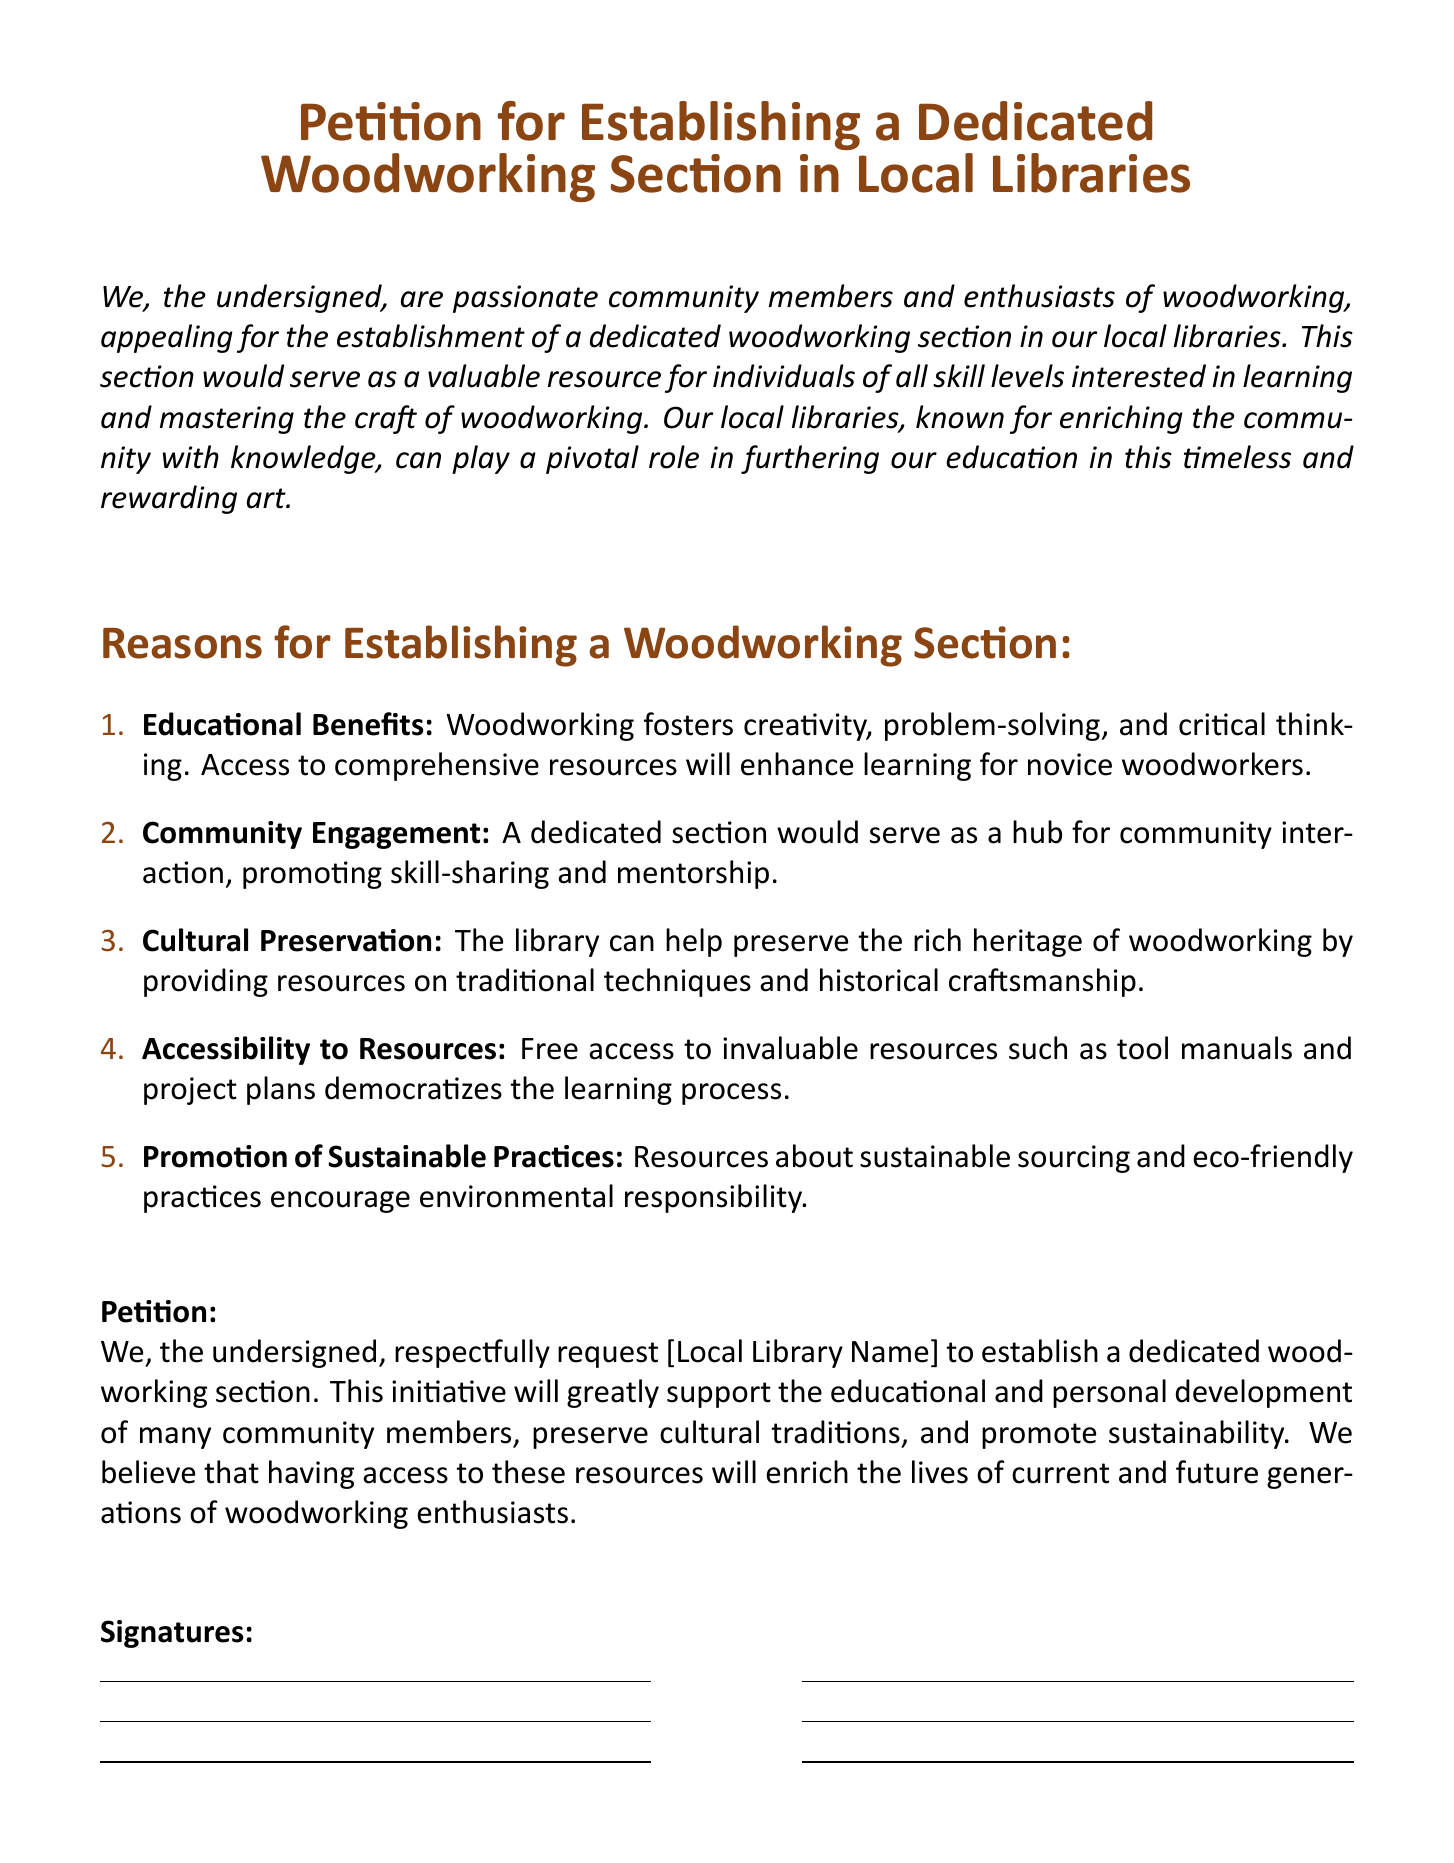What is the title of the petition? The title of the petition is prominently displayed at the top of the document.
Answer: Petition for Establishing a Dedicated Woodworking Section in Local Libraries How many reasons are listed for establishing a woodworking section? The document enumerates a list of reasons.
Answer: Five What is the first reason mentioned in the document? The first reason is clearly stated at the start of the enumerated list.
Answer: Educational Benefits What does the petition request from the local library? The main request is articulated in the petition section.
Answer: To establish a dedicated woodworking section What color is used for the section titles? The titles are formatted with a specific color for emphasis.
Answer: Woodbrown What is one aspect related to sustainability mentioned in the document? The document discusses various elements related to environmental responsibility.
Answer: Eco-friendly practices Who is the target audience for the proposed woodworking section? The petition addresses a specific group interested in woodworking.
Answer: Individuals of all skill levels What kind of engagement does the document promote with the woodworking section? The document highlights a particular type of interaction among community members.
Answer: Community Engagement 